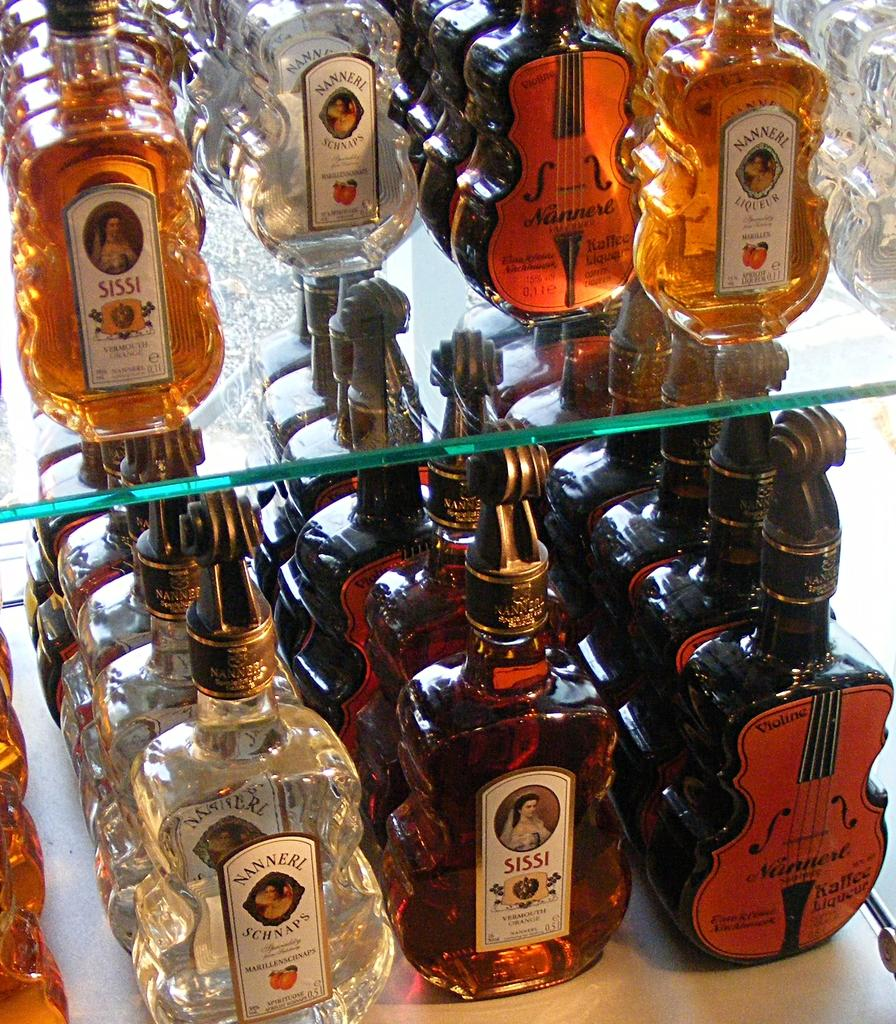<image>
Provide a brief description of the given image. Many bottles of alcohol on a shelf including one that is named "SISSI". 